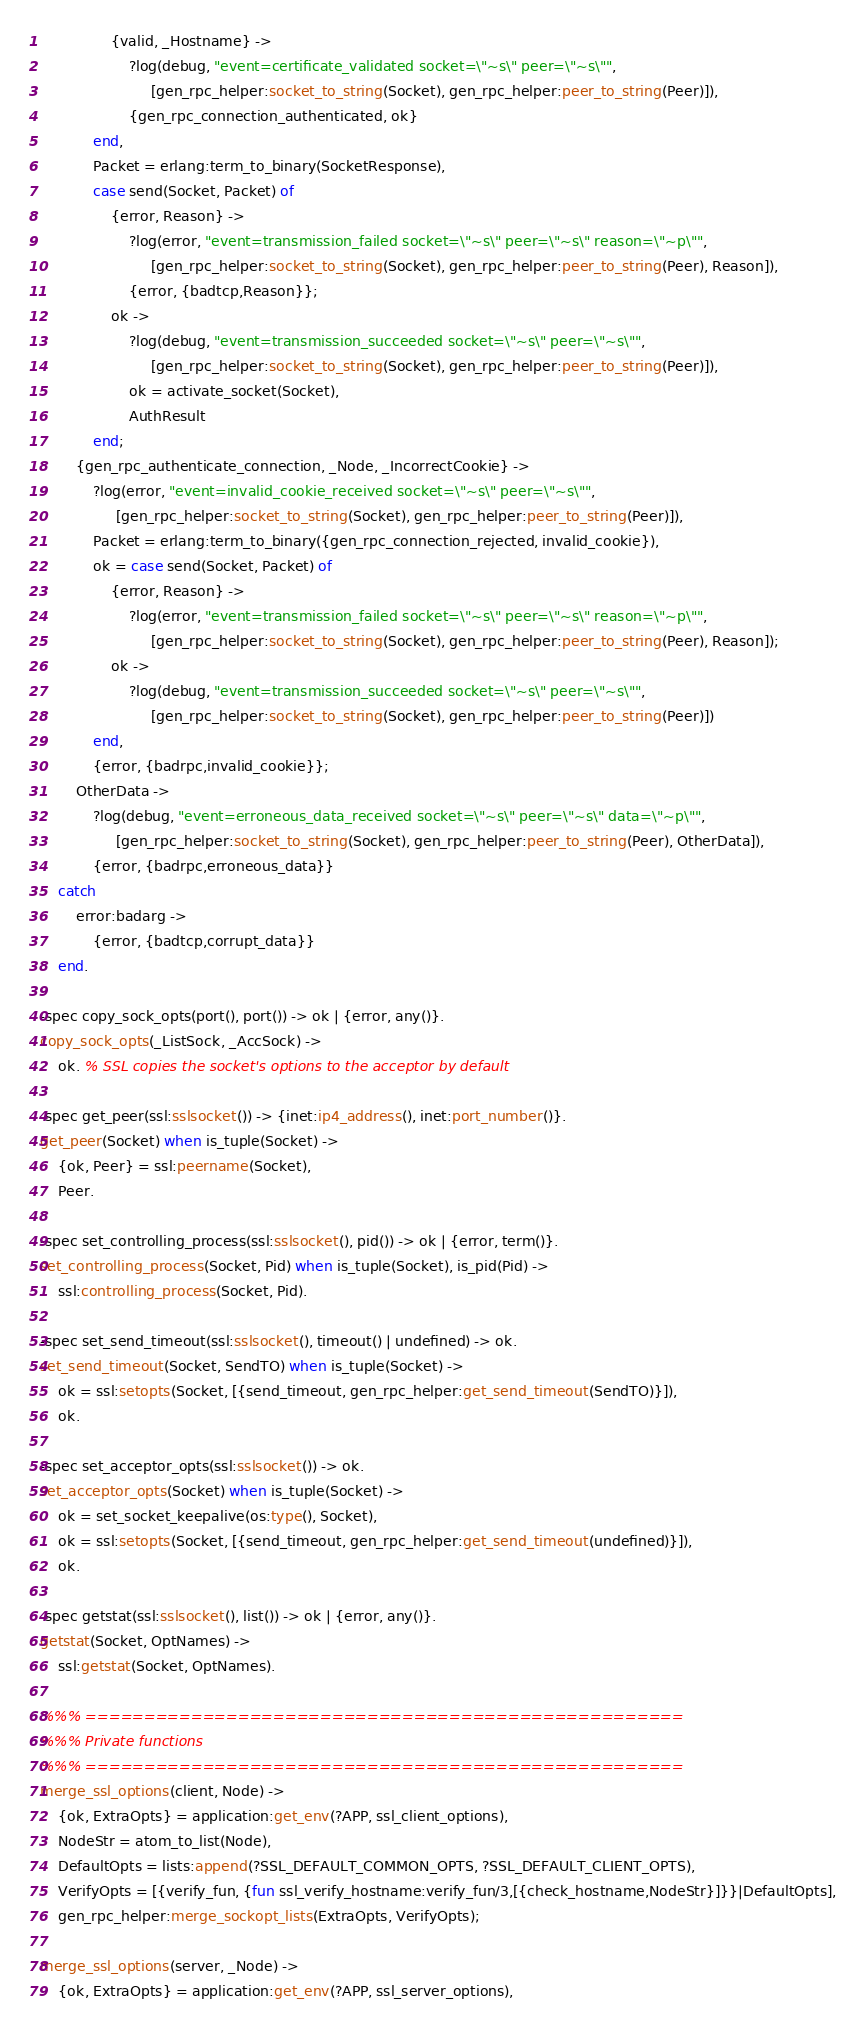Convert code to text. <code><loc_0><loc_0><loc_500><loc_500><_Erlang_>                {valid, _Hostname} ->
                    ?log(debug, "event=certificate_validated socket=\"~s\" peer=\"~s\"",
                         [gen_rpc_helper:socket_to_string(Socket), gen_rpc_helper:peer_to_string(Peer)]),
                    {gen_rpc_connection_authenticated, ok}
            end,
            Packet = erlang:term_to_binary(SocketResponse),
            case send(Socket, Packet) of
                {error, Reason} ->
                    ?log(error, "event=transmission_failed socket=\"~s\" peer=\"~s\" reason=\"~p\"",
                         [gen_rpc_helper:socket_to_string(Socket), gen_rpc_helper:peer_to_string(Peer), Reason]),
                    {error, {badtcp,Reason}};
                ok ->
                    ?log(debug, "event=transmission_succeeded socket=\"~s\" peer=\"~s\"",
                         [gen_rpc_helper:socket_to_string(Socket), gen_rpc_helper:peer_to_string(Peer)]),
                    ok = activate_socket(Socket),
                    AuthResult
            end;
        {gen_rpc_authenticate_connection, _Node, _IncorrectCookie} ->
            ?log(error, "event=invalid_cookie_received socket=\"~s\" peer=\"~s\"",
                 [gen_rpc_helper:socket_to_string(Socket), gen_rpc_helper:peer_to_string(Peer)]),
            Packet = erlang:term_to_binary({gen_rpc_connection_rejected, invalid_cookie}),
            ok = case send(Socket, Packet) of
                {error, Reason} ->
                    ?log(error, "event=transmission_failed socket=\"~s\" peer=\"~s\" reason=\"~p\"",
                         [gen_rpc_helper:socket_to_string(Socket), gen_rpc_helper:peer_to_string(Peer), Reason]);
                ok ->
                    ?log(debug, "event=transmission_succeeded socket=\"~s\" peer=\"~s\"",
                         [gen_rpc_helper:socket_to_string(Socket), gen_rpc_helper:peer_to_string(Peer)])
            end,
            {error, {badrpc,invalid_cookie}};
        OtherData ->
            ?log(debug, "event=erroneous_data_received socket=\"~s\" peer=\"~s\" data=\"~p\"",
                 [gen_rpc_helper:socket_to_string(Socket), gen_rpc_helper:peer_to_string(Peer), OtherData]),
            {error, {badrpc,erroneous_data}}
    catch
        error:badarg ->
            {error, {badtcp,corrupt_data}}
    end.

-spec copy_sock_opts(port(), port()) -> ok | {error, any()}.
copy_sock_opts(_ListSock, _AccSock) ->
    ok. % SSL copies the socket's options to the acceptor by default

-spec get_peer(ssl:sslsocket()) -> {inet:ip4_address(), inet:port_number()}.
get_peer(Socket) when is_tuple(Socket) ->
    {ok, Peer} = ssl:peername(Socket),
    Peer.

-spec set_controlling_process(ssl:sslsocket(), pid()) -> ok | {error, term()}.
set_controlling_process(Socket, Pid) when is_tuple(Socket), is_pid(Pid) ->
    ssl:controlling_process(Socket, Pid).

-spec set_send_timeout(ssl:sslsocket(), timeout() | undefined) -> ok.
set_send_timeout(Socket, SendTO) when is_tuple(Socket) ->
    ok = ssl:setopts(Socket, [{send_timeout, gen_rpc_helper:get_send_timeout(SendTO)}]),
    ok.

-spec set_acceptor_opts(ssl:sslsocket()) -> ok.
set_acceptor_opts(Socket) when is_tuple(Socket) ->
    ok = set_socket_keepalive(os:type(), Socket),
    ok = ssl:setopts(Socket, [{send_timeout, gen_rpc_helper:get_send_timeout(undefined)}]),
    ok.

-spec getstat(ssl:sslsocket(), list()) -> ok | {error, any()}.
getstat(Socket, OptNames) ->
    ssl:getstat(Socket, OptNames).

%%% ===================================================
%%% Private functions
%%% ===================================================
merge_ssl_options(client, Node) ->
    {ok, ExtraOpts} = application:get_env(?APP, ssl_client_options),
    NodeStr = atom_to_list(Node),
    DefaultOpts = lists:append(?SSL_DEFAULT_COMMON_OPTS, ?SSL_DEFAULT_CLIENT_OPTS),
    VerifyOpts = [{verify_fun, {fun ssl_verify_hostname:verify_fun/3,[{check_hostname,NodeStr}]}}|DefaultOpts],
    gen_rpc_helper:merge_sockopt_lists(ExtraOpts, VerifyOpts);

merge_ssl_options(server, _Node) ->
    {ok, ExtraOpts} = application:get_env(?APP, ssl_server_options),</code> 